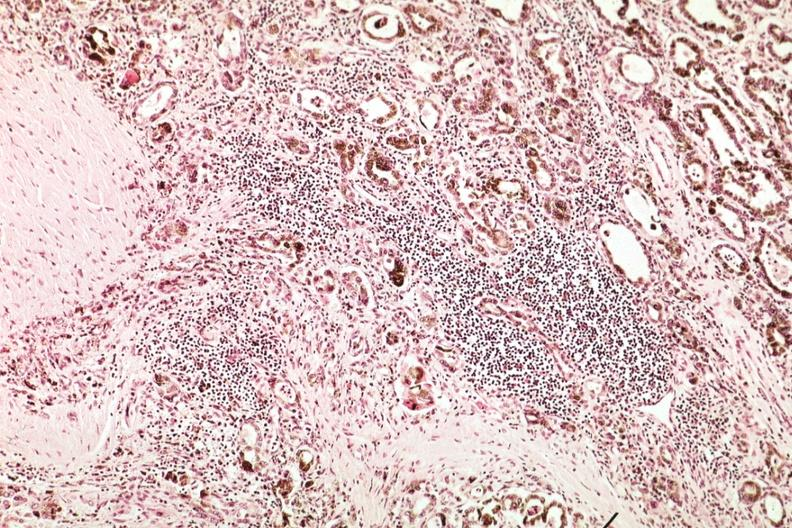does this typical lesion show marked atrophy with iron in epithelium and lymphocytic infiltrate?
Answer the question using a single word or phrase. No 